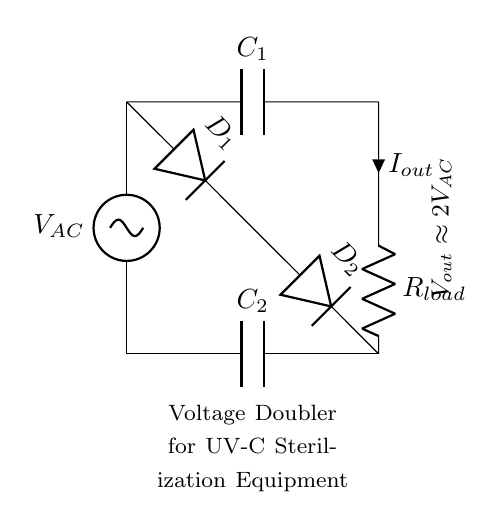What is the main function of this circuit? The main function of the circuit is to double the input AC voltage to charge the UV-C sterilization equipment effectively. This is indicated by the output voltage being approximately double the AC input voltage.
Answer: Voltage doubler What are the two types of components used in this rectifier circuit? The components include diodes and capacitors, which work together to convert AC voltage to a DC voltage and store energy for the output.
Answer: Diodes and capacitors What is the value of the output voltage? The output voltage is approximately double the input AC voltage, so if the input is known (for example, if V AC is 120V), the output will be around 240V.
Answer: Approximately 2 V AC How many diodes are used in the circuit? The circuit contains two diodes which are essential for the rectification process, allowing current to flow in one direction only.
Answer: Two What is the purpose of the load resistor in this circuit? The load resistor serves to limit the current flow from the output, ensuring safe operation and preventing damage to the sterilization equipment connected to the circuit.
Answer: Limit current flow Why is a voltage doubler circuit used for UV-C sterilization equipment? A voltage doubler circuit is used as it can provide higher voltage output suitable for powering UV-C sterilization devices, which require a significant voltage to operate effectively.
Answer: To provide higher voltage 